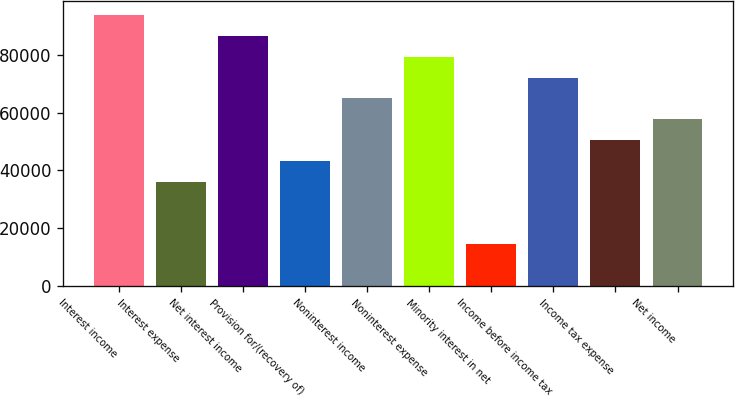Convert chart to OTSL. <chart><loc_0><loc_0><loc_500><loc_500><bar_chart><fcel>Interest income<fcel>Interest expense<fcel>Net interest income<fcel>Provision for/(recovery of)<fcel>Noninterest income<fcel>Noninterest expense<fcel>Minority interest in net<fcel>Income before income tax<fcel>Income tax expense<fcel>Net income<nl><fcel>93837.7<fcel>36091.8<fcel>86619.5<fcel>43310<fcel>64964.8<fcel>79401.2<fcel>14437.1<fcel>72183<fcel>50528.3<fcel>57746.5<nl></chart> 